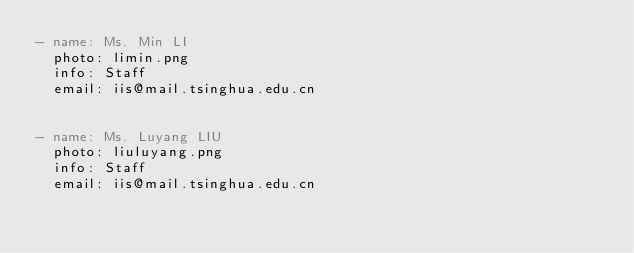Convert code to text. <code><loc_0><loc_0><loc_500><loc_500><_YAML_>- name: Ms. Min LI
  photo: limin.png
  info: Staff
  email: iis@mail.tsinghua.edu.cn
 

- name: Ms. Luyang LIU
  photo: liuluyang.png
  info: Staff
  email: iis@mail.tsinghua.edu.cn

</code> 